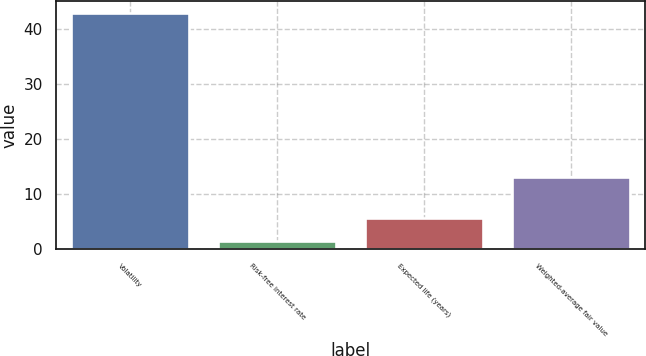<chart> <loc_0><loc_0><loc_500><loc_500><bar_chart><fcel>Volatility<fcel>Risk-free interest rate<fcel>Expected life (years)<fcel>Weighted-average fair value<nl><fcel>43<fcel>1.5<fcel>5.65<fcel>13.17<nl></chart> 